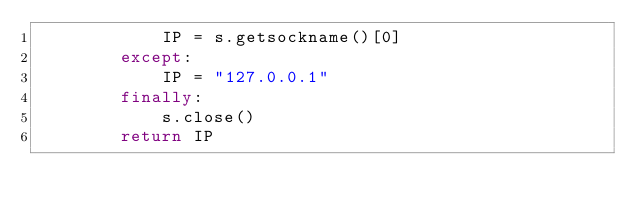<code> <loc_0><loc_0><loc_500><loc_500><_Python_>            IP = s.getsockname()[0]
        except:
            IP = "127.0.0.1"
        finally:
            s.close()
        return IP
</code> 